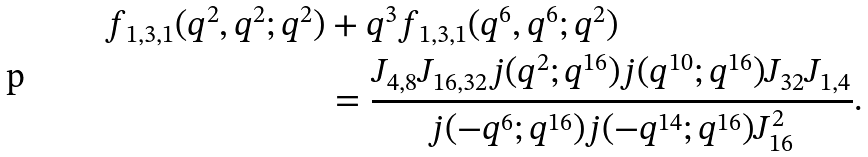<formula> <loc_0><loc_0><loc_500><loc_500>f _ { 1 , 3 , 1 } ( q ^ { 2 } , q ^ { 2 } ; q ^ { 2 } ) & + q ^ { 3 } f _ { 1 , 3 , 1 } ( q ^ { 6 } , q ^ { 6 } ; q ^ { 2 } ) \\ & = \frac { J _ { 4 , 8 } J _ { 1 6 , 3 2 } j ( q ^ { 2 } ; q ^ { 1 6 } ) j ( q ^ { 1 0 } ; q ^ { 1 6 } ) J _ { 3 2 } J _ { 1 , 4 } } { j ( - q ^ { 6 } ; q ^ { 1 6 } ) j ( - q ^ { 1 4 } ; q ^ { 1 6 } ) J _ { 1 6 } ^ { 2 } } .</formula> 